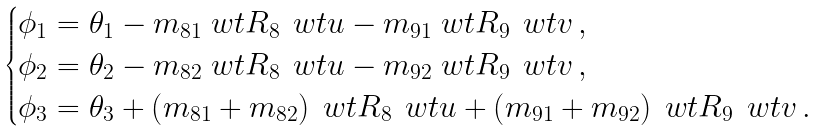<formula> <loc_0><loc_0><loc_500><loc_500>\begin{cases} \phi _ { 1 } = \theta _ { 1 } - m _ { 8 1 } \ w t R _ { 8 } \, \ w t u - m _ { 9 1 } \ w t R _ { 9 } \, \ w t v \, , \\ \phi _ { 2 } = \theta _ { 2 } - m _ { 8 2 } \ w t R _ { 8 } \, \ w t u - m _ { 9 2 } \ w t R _ { 9 } \, \ w t v \, , \\ \phi _ { 3 } = \theta _ { 3 } + \left ( m _ { 8 1 } + m _ { 8 2 } \right ) \ w t R _ { 8 } \, \ w t u + \left ( m _ { 9 1 } + m _ { 9 2 } \right ) \ w t R _ { 9 } \, \ w t v \, . \\ \end{cases}</formula> 